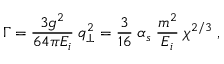Convert formula to latex. <formula><loc_0><loc_0><loc_500><loc_500>\Gamma = \frac { 3 g ^ { 2 } } { 6 4 \pi E _ { i } } \, q _ { \bot } ^ { 2 } = \frac { 3 } { 1 6 } \, \alpha _ { s } \, \frac { m ^ { 2 } } { E _ { i } } \, \chi ^ { 2 / 3 } \, ,</formula> 